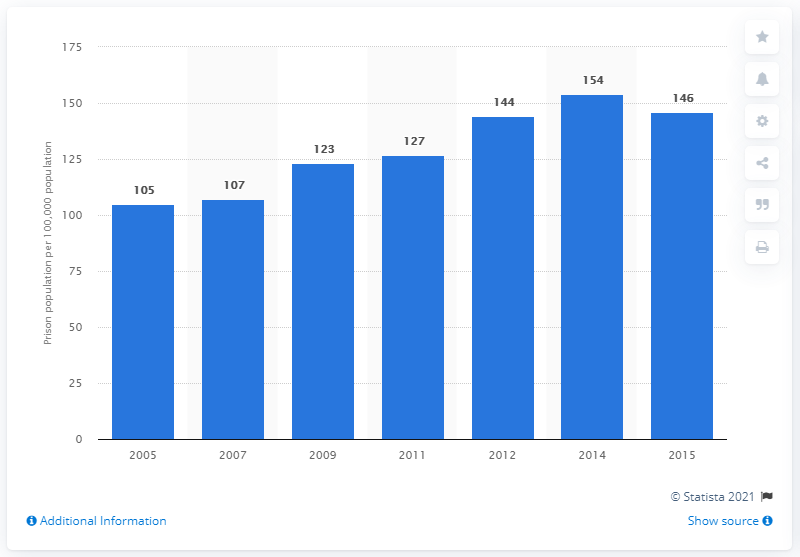Give some essential details in this illustration. In 2015, the prison population rate in Vietnam was 146 per 100,000 people. 